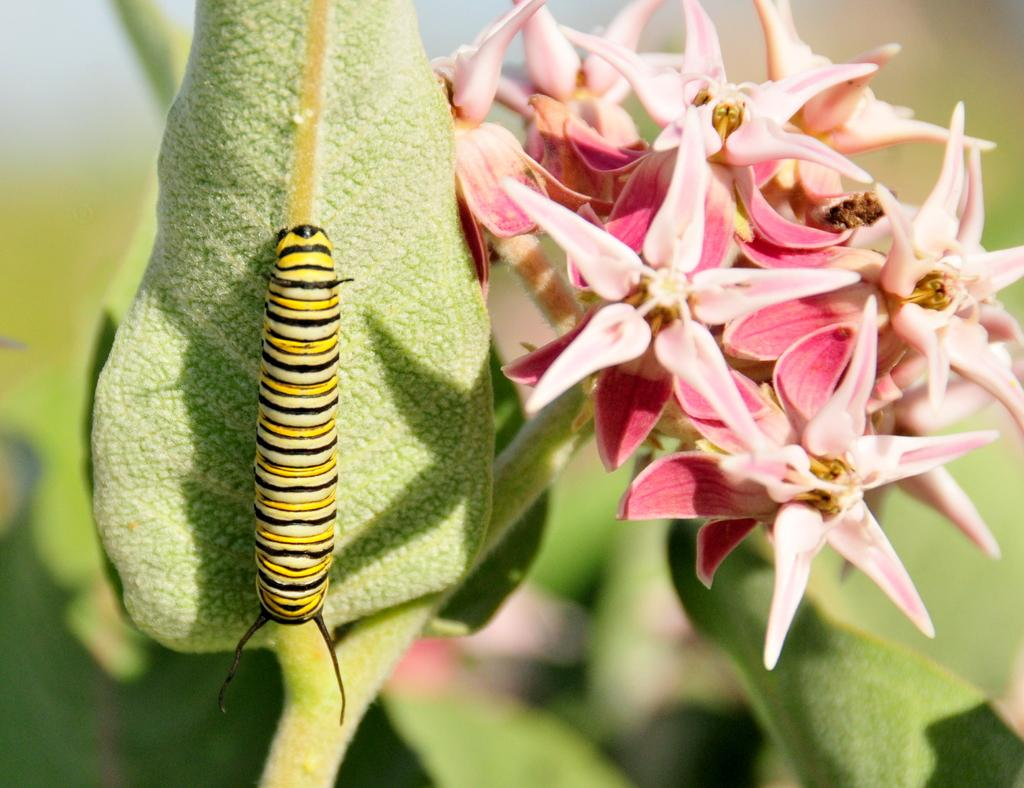Where was the image taken? The image was taken outdoors. What can be seen in the image besides the outdoor setting? There is a plant with flowers in the image. What color are the flowers? The flowers are pink in color. Are there any animals visible in the image? Yes, there is a caterpillar on a leaf in the image. How does the yam contribute to the expansion of the family in the image? There is no yam present in the image, and therefore it cannot contribute to the expansion of the family. 